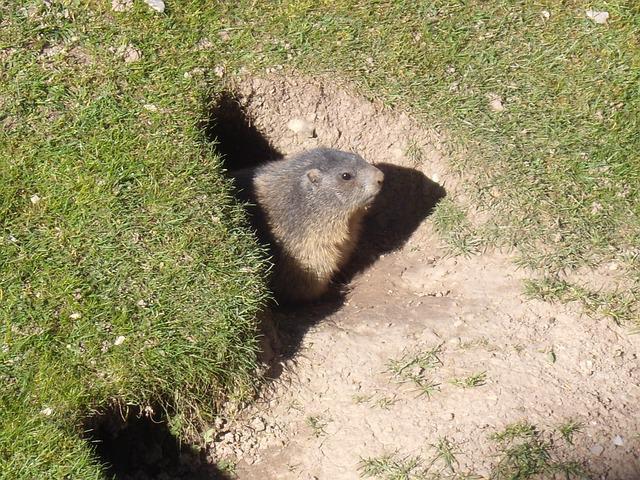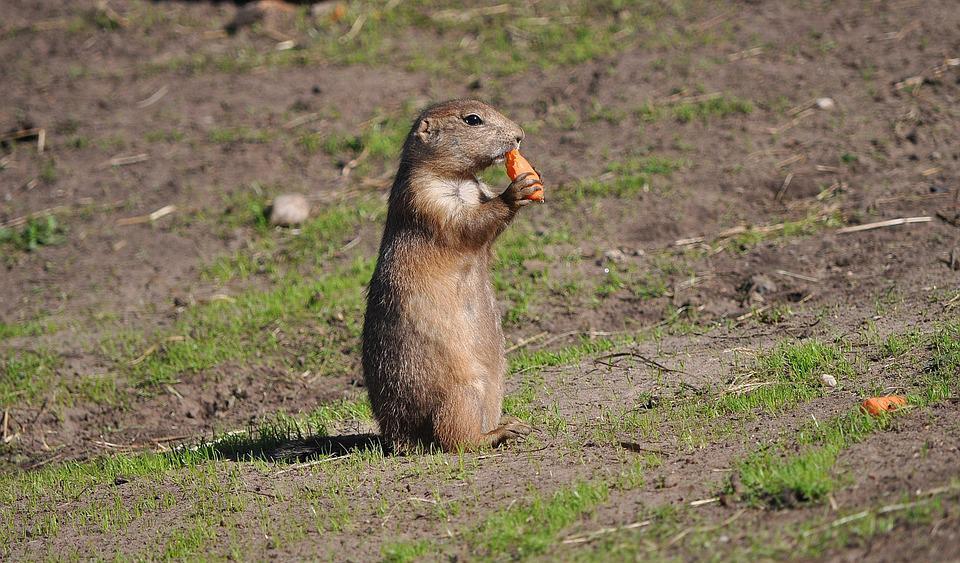The first image is the image on the left, the second image is the image on the right. Considering the images on both sides, is "The image on the right shows a single marmot standing on its back legs eating food." valid? Answer yes or no. Yes. The first image is the image on the left, the second image is the image on the right. Assess this claim about the two images: "In one image, an animal is eating.". Correct or not? Answer yes or no. Yes. 